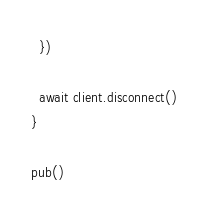<code> <loc_0><loc_0><loc_500><loc_500><_JavaScript_>  })

  await client.disconnect()
}

pub()
</code> 